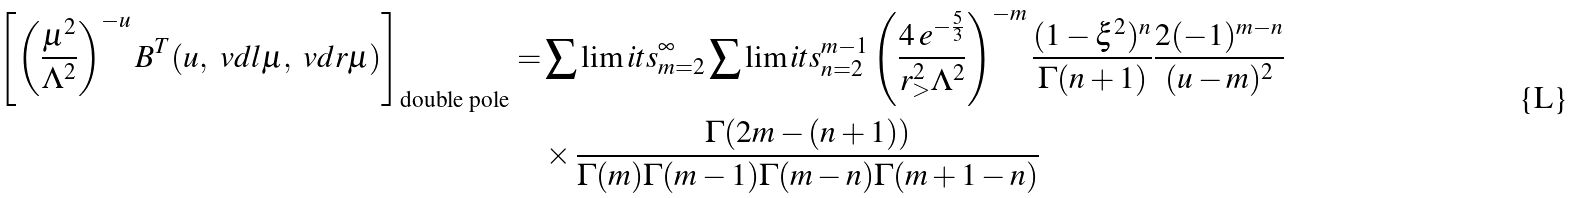<formula> <loc_0><loc_0><loc_500><loc_500>\left [ \left ( \frac { \mu ^ { 2 } } { \Lambda ^ { 2 } } \right ) ^ { - u } B ^ { T } ( u , \ v d l \mu , \ v d r \mu ) \right ] _ { \text {double pole} } = & \sum \lim i t s _ { m = 2 } ^ { \infty } \sum \lim i t s _ { n = 2 } ^ { m - 1 } \left ( \frac { 4 \, e ^ { - \frac { 5 } { 3 } } } { r _ { > } ^ { 2 } \Lambda ^ { 2 } } \right ) ^ { - m } \frac { ( 1 - \xi ^ { 2 } ) ^ { n } } { \Gamma ( n + 1 ) } \frac { 2 ( - 1 ) ^ { m - n } } { ( u - m ) ^ { 2 } } \\ & \times \frac { \Gamma ( 2 m - ( n + 1 ) ) } { \Gamma ( m ) \Gamma ( m - 1 ) \Gamma ( m - n ) \Gamma ( m + 1 - n ) }</formula> 